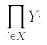<formula> <loc_0><loc_0><loc_500><loc_500>\prod _ { i \in X } Y _ { i }</formula> 